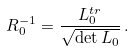<formula> <loc_0><loc_0><loc_500><loc_500>R _ { 0 } ^ { - 1 } = \frac { L _ { 0 } ^ { t r } } { \sqrt { \det L _ { 0 } } } \, .</formula> 